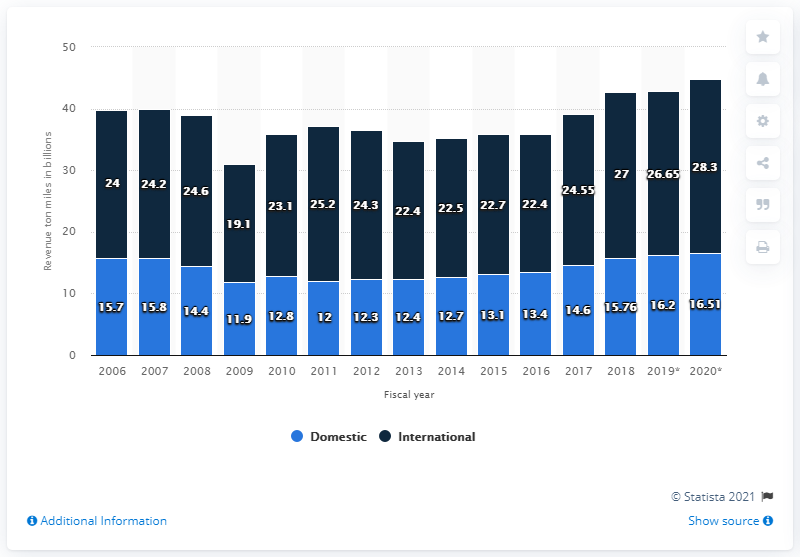Give some essential details in this illustration. In 2019, U.S. commercial air carriers reported a total of 16.2 billion ton-miles of domestic cargo revenue. 